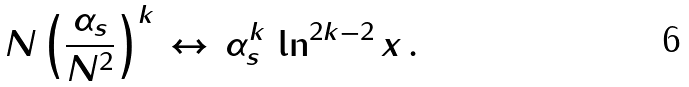<formula> <loc_0><loc_0><loc_500><loc_500>N \left ( \frac { \alpha _ { s } } { N ^ { 2 } } \right ) ^ { k } \, \leftrightarrow \, \alpha _ { s } ^ { k } \, \ln ^ { 2 k - 2 } x \, .</formula> 